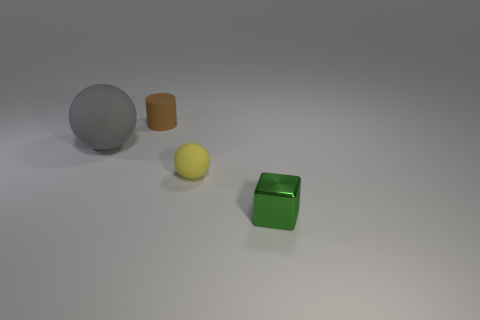Is there any other thing that has the same color as the large matte sphere?
Offer a very short reply. No. The tiny brown thing that is made of the same material as the gray thing is what shape?
Offer a terse response. Cylinder. What material is the tiny cylinder behind the large ball?
Your answer should be very brief. Rubber. Is the color of the matte thing that is on the left side of the matte cylinder the same as the tiny sphere?
Provide a short and direct response. No. What size is the object on the left side of the matte thing that is behind the big gray matte object?
Offer a very short reply. Large. Is the number of blocks that are to the right of the tiny green metallic block greater than the number of small yellow rubber balls?
Offer a very short reply. No. There is a matte thing that is in front of the gray ball; is it the same size as the gray object?
Keep it short and to the point. No. The thing that is in front of the brown thing and behind the yellow matte sphere is what color?
Offer a very short reply. Gray. There is a brown thing that is the same size as the yellow rubber object; what is its shape?
Give a very brief answer. Cylinder. Are there any rubber cylinders that have the same color as the big rubber sphere?
Your answer should be compact. No. 